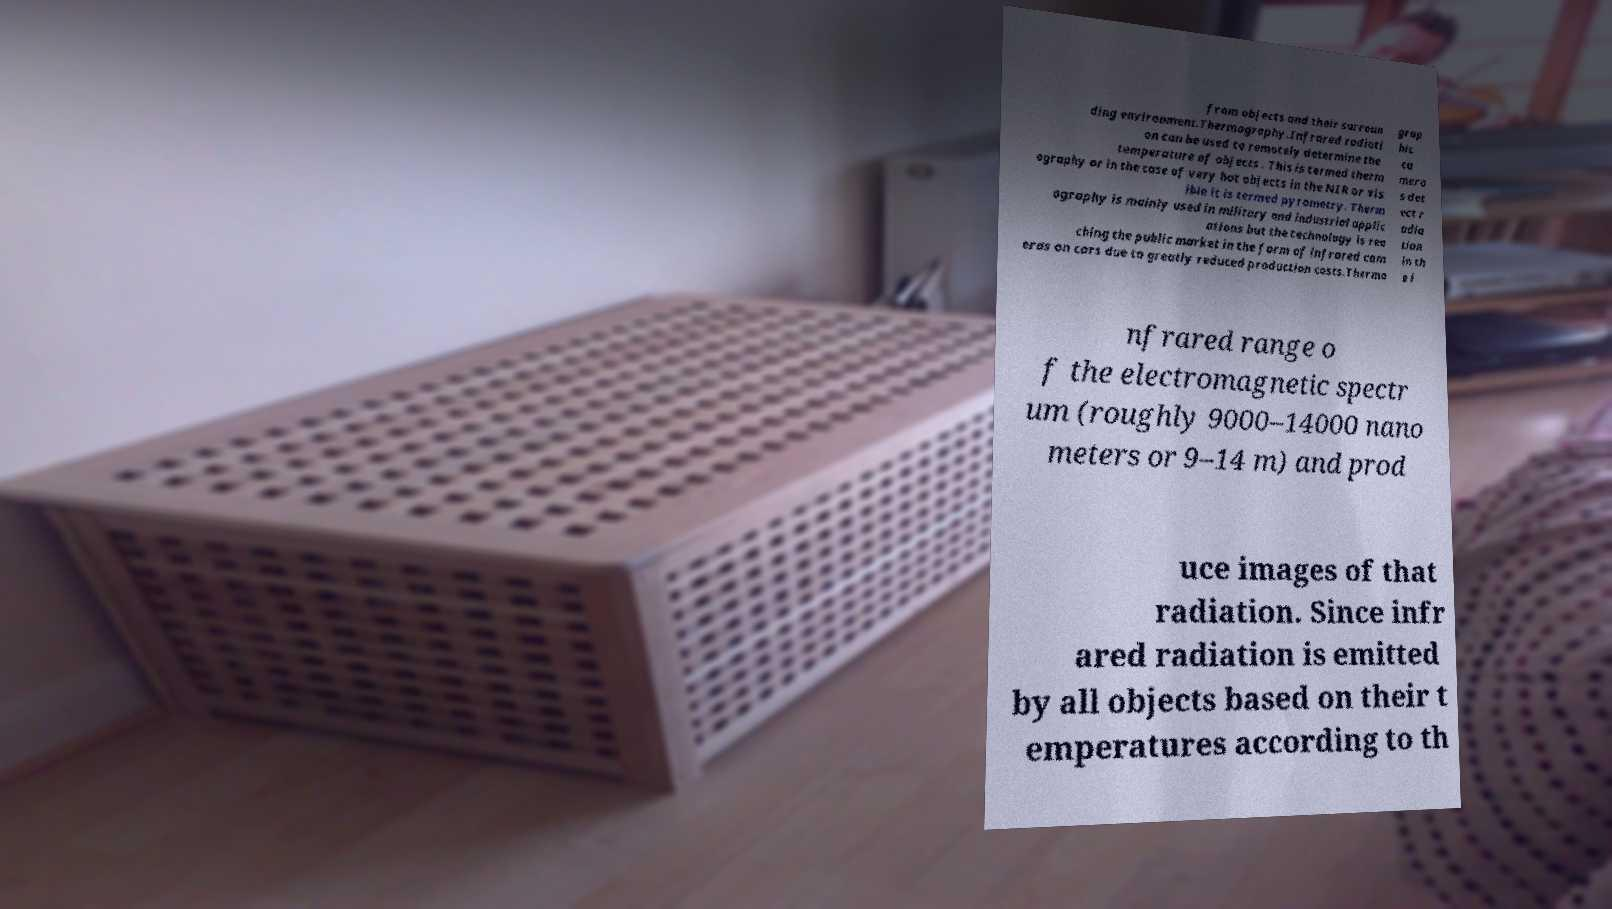What messages or text are displayed in this image? I need them in a readable, typed format. from objects and their surroun ding environment.Thermography.Infrared radiati on can be used to remotely determine the temperature of objects . This is termed therm ography or in the case of very hot objects in the NIR or vis ible it is termed pyrometry. Therm ography is mainly used in military and industrial applic ations but the technology is rea ching the public market in the form of infrared cam eras on cars due to greatly reduced production costs.Thermo grap hic ca mera s det ect r adia tion in th e i nfrared range o f the electromagnetic spectr um (roughly 9000–14000 nano meters or 9–14 m) and prod uce images of that radiation. Since infr ared radiation is emitted by all objects based on their t emperatures according to th 